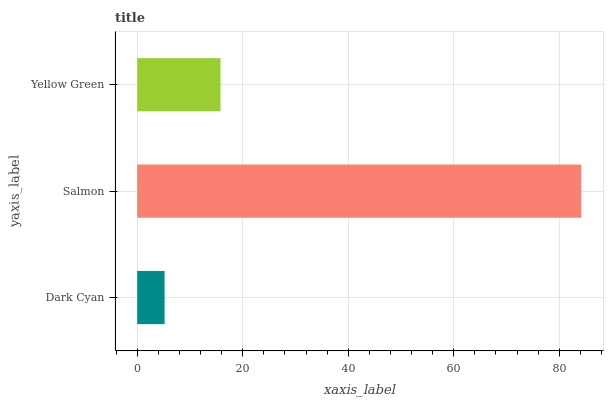Is Dark Cyan the minimum?
Answer yes or no. Yes. Is Salmon the maximum?
Answer yes or no. Yes. Is Yellow Green the minimum?
Answer yes or no. No. Is Yellow Green the maximum?
Answer yes or no. No. Is Salmon greater than Yellow Green?
Answer yes or no. Yes. Is Yellow Green less than Salmon?
Answer yes or no. Yes. Is Yellow Green greater than Salmon?
Answer yes or no. No. Is Salmon less than Yellow Green?
Answer yes or no. No. Is Yellow Green the high median?
Answer yes or no. Yes. Is Yellow Green the low median?
Answer yes or no. Yes. Is Salmon the high median?
Answer yes or no. No. Is Salmon the low median?
Answer yes or no. No. 